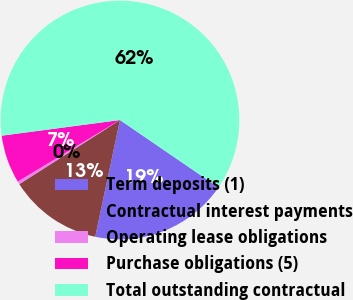<chart> <loc_0><loc_0><loc_500><loc_500><pie_chart><fcel>Term deposits (1)<fcel>Contractual interest payments<fcel>Operating lease obligations<fcel>Purchase obligations (5)<fcel>Total outstanding contractual<nl><fcel>18.78%<fcel>12.65%<fcel>0.4%<fcel>6.53%<fcel>61.65%<nl></chart> 